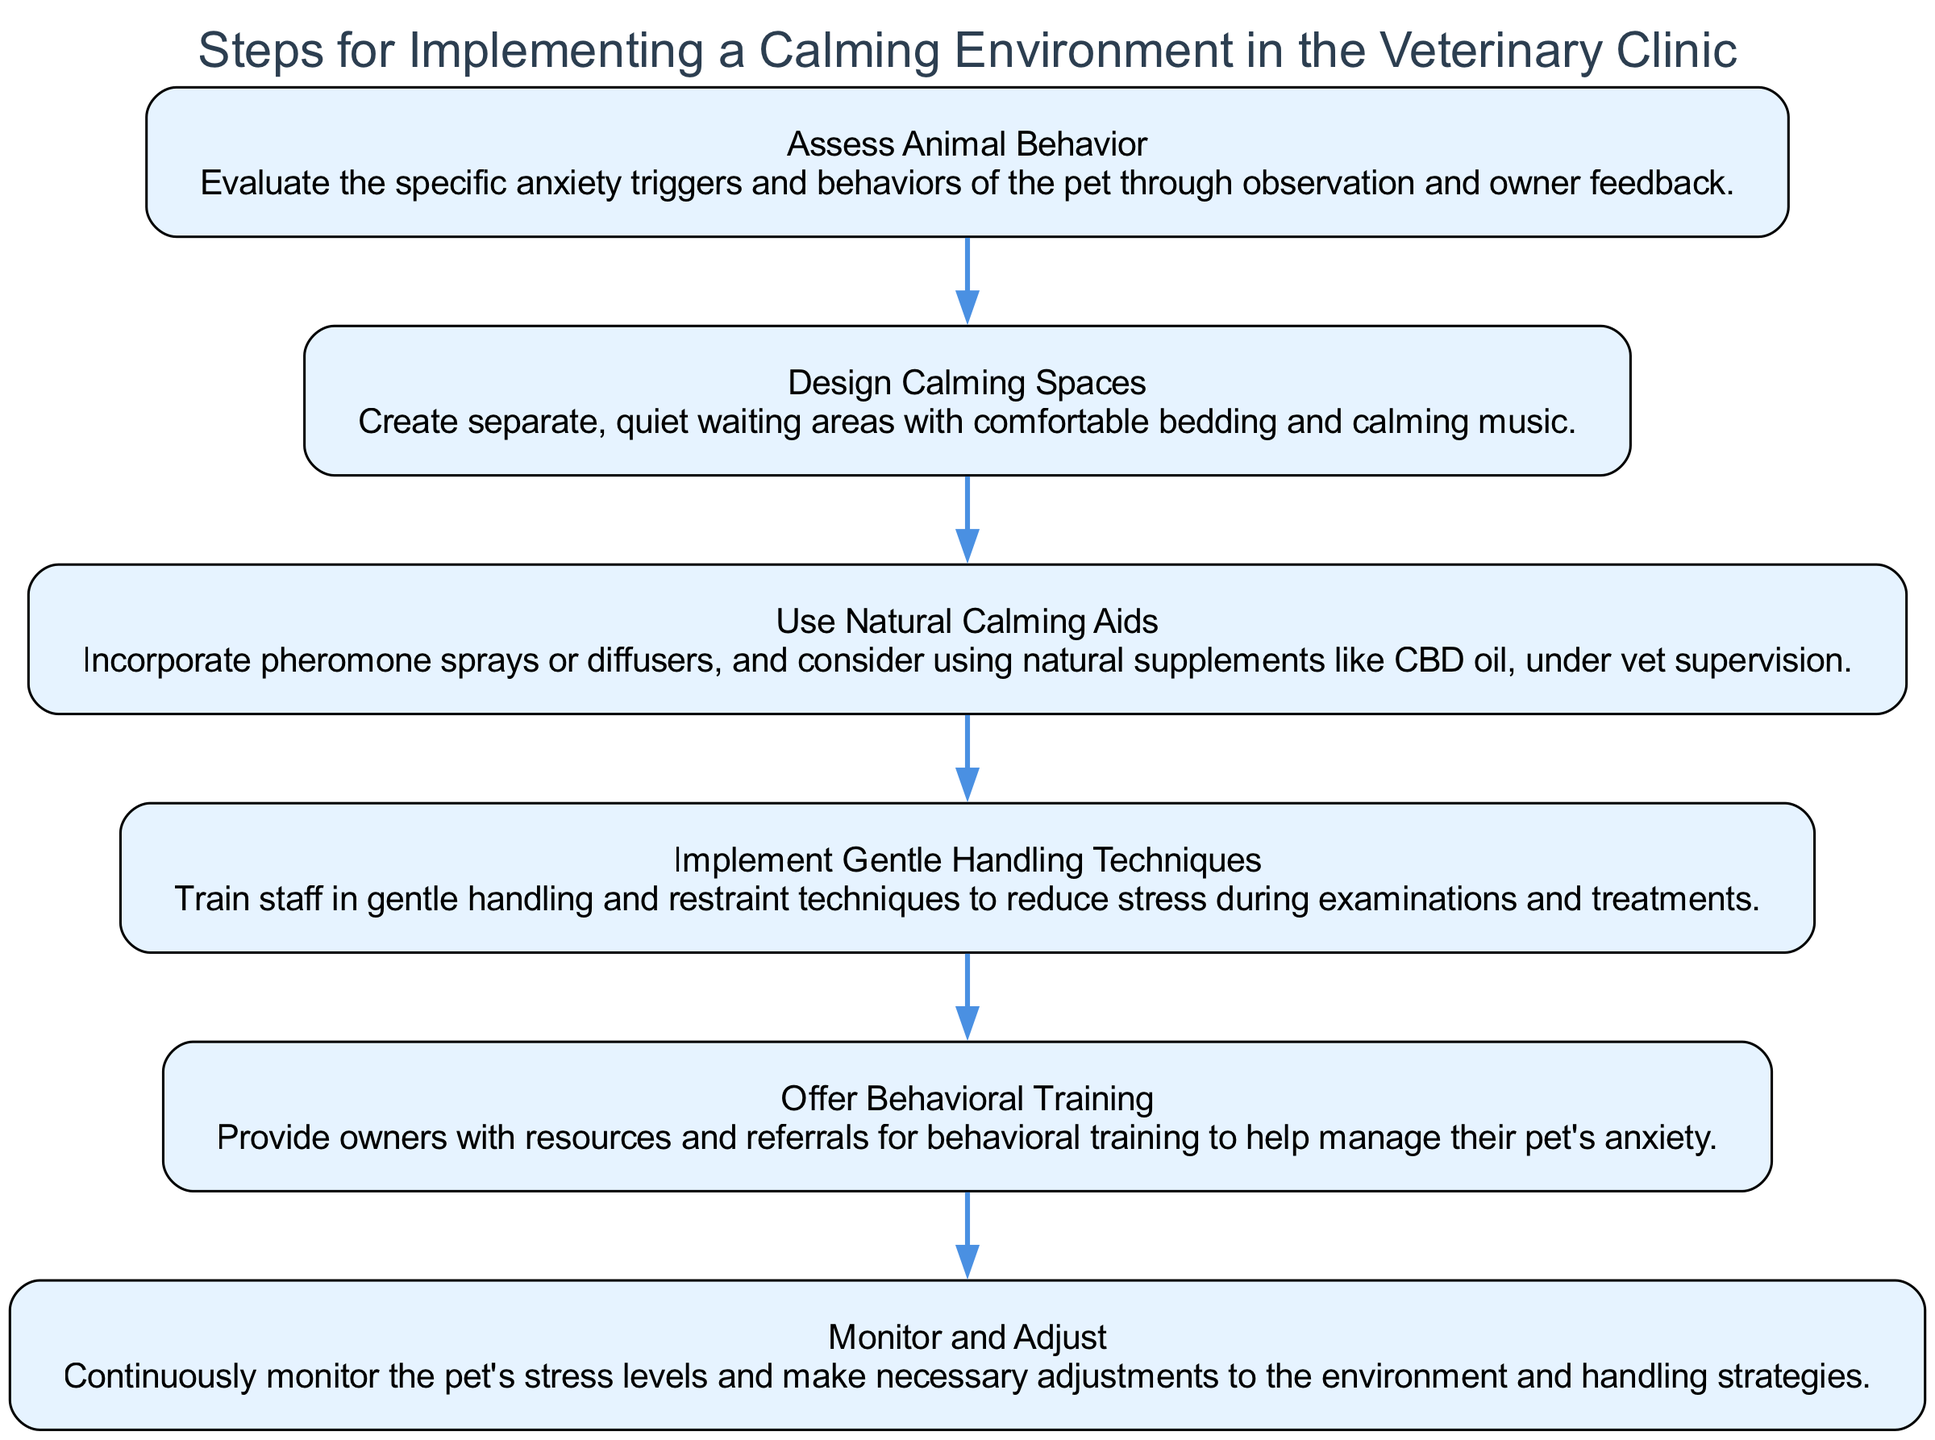What is the first step in the diagram? The first step listed in the diagram is "Assess Animal Behavior". This is the initial action taken to start implementing a calming environment.
Answer: Assess Animal Behavior How many steps are there in total? The diagram includes a total of six steps that outline the process for implementing a calming environment.
Answer: Six What is incorporated in the third step? The third step involves the use of "Natural Calming Aids", which includes pheromone sprays or diffusers and natural supplements like CBD oil.
Answer: Natural Calming Aids Which step follows "Design Calming Spaces"? The step that follows "Design Calming Spaces" is "Use Natural Calming Aids". This shows a direct transition in the flow of implementing calming measures.
Answer: Use Natural Calming Aids Which step provides resources for pet owners? The step titled "Offer Behavioral Training" provides resources and referrals for pet owners to help manage their pet's anxiety.
Answer: Offer Behavioral Training Explain the relationship between "Implement Gentle Handling Techniques" and "Monitor and Adjust". "Implement Gentle Handling Techniques" is the fourth step, and it leads directly to "Monitor and Adjust" as the last step, indicating that after handling techniques are established, ongoing observation of the pet's stress levels and adjustments are made respectively to ensure effectiveness.
Answer: Implement Gentle Handling Techniques leads to Monitor and Adjust What kind of environment is suggested in "Design Calming Spaces"? "Design Calming Spaces" suggests creating "quiet waiting areas" equipped with "comfortable bedding" and "calming music" to help soothe anxious pets.
Answer: Quiet waiting areas with comfortable bedding and calming music What step involves staff training? The step that involves staff training is "Implement Gentle Handling Techniques," which emphasizes training staff in techniques to reduce pet stress.
Answer: Implement Gentle Handling Techniques 